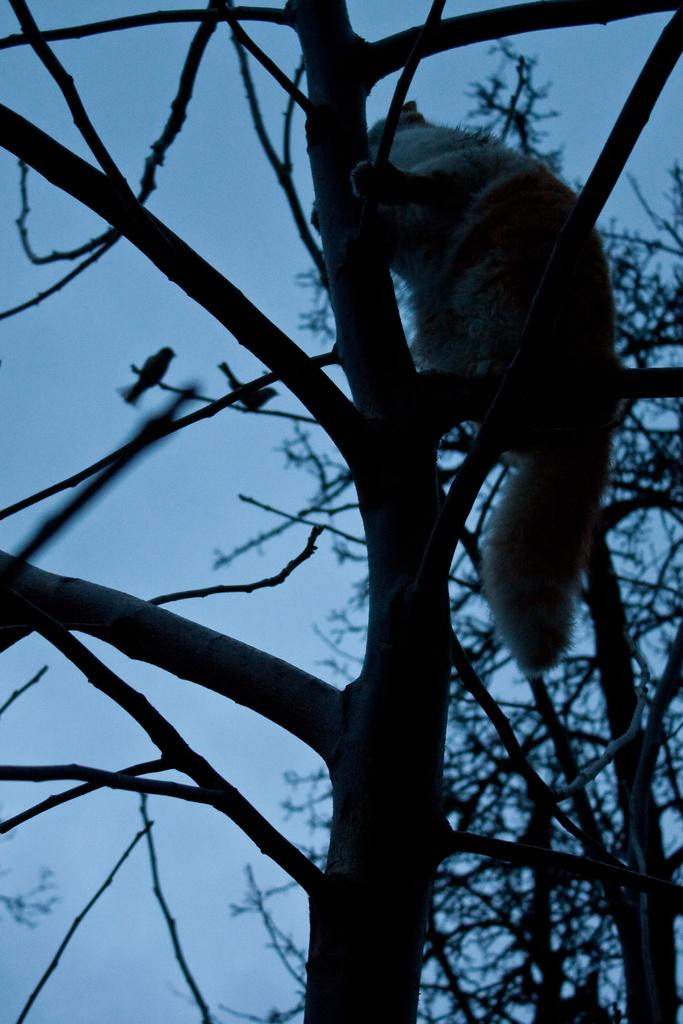What type of animal is present in the image? There is an animal in the image, but its specific type cannot be determined from the provided facts. What can be seen on the branches in the image? There are two birds on the branches in the image. What is located behind the animal in the image? There are trees behind the animal in the image. What is visible in the background of the image? The sky is visible in the image. What type of needle is being used by the animal in the image? There is no needle present in the image; it features an animal, birds, trees, and the sky. 